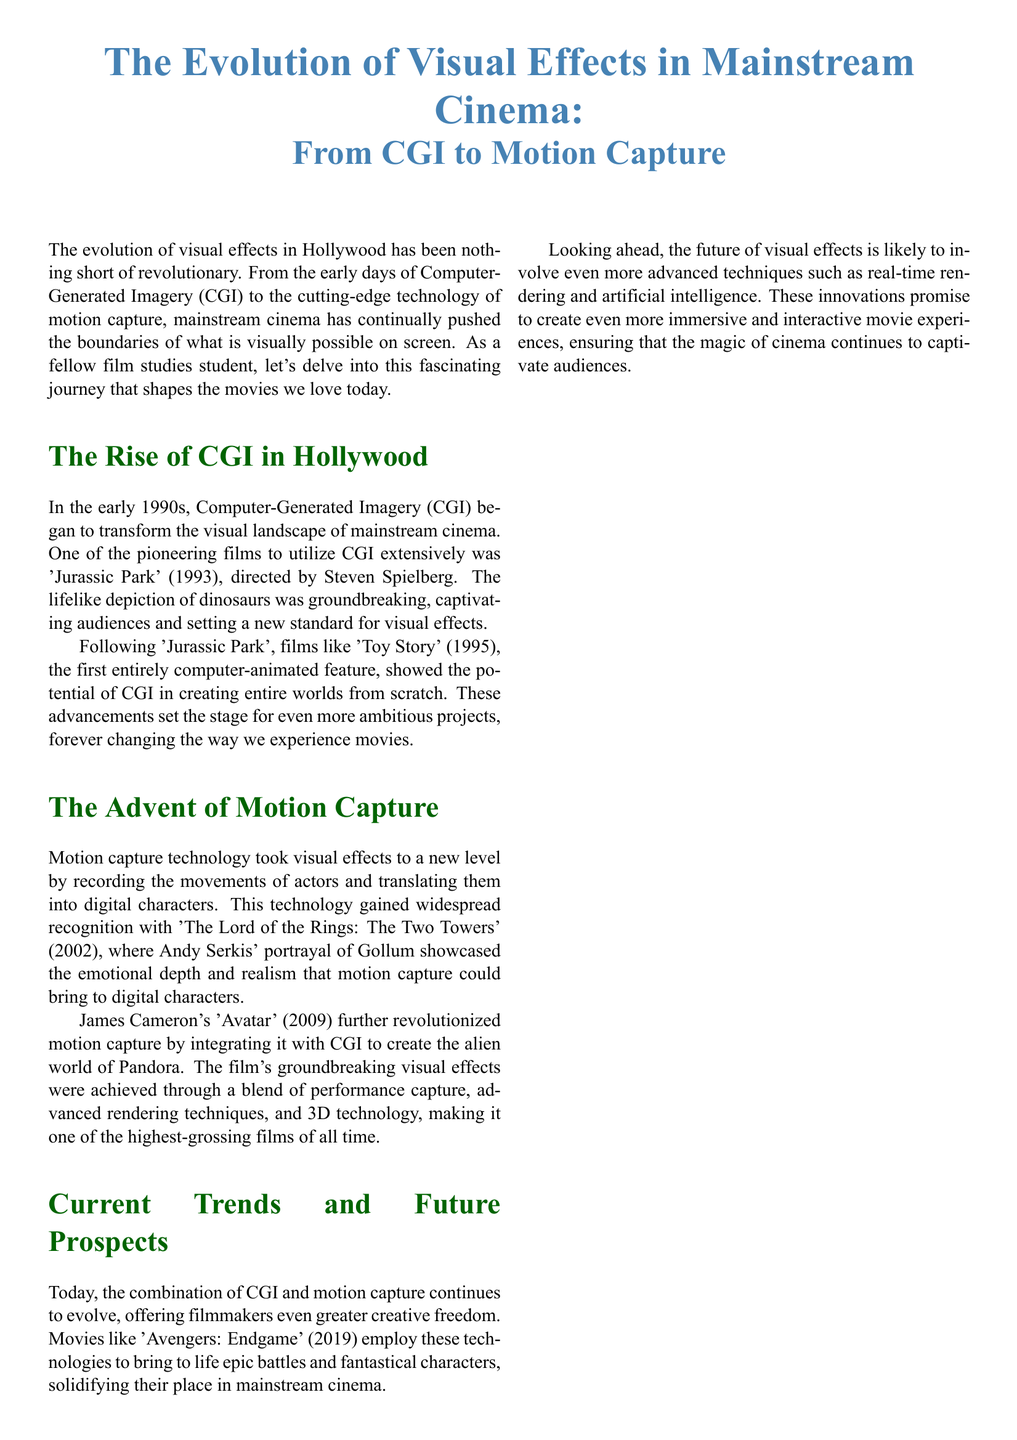What film is known for its groundbreaking use of CGI? The document states that 'Jurassic Park' was one of the pioneering films to utilize CGI extensively.
Answer: 'Jurassic Park' In what year was 'Toy Story' released? According to the document, 'Toy Story' was released in 1995.
Answer: 1995 Who portrayed Gollum in 'The Lord of the Rings: The Two Towers'? The document mentions that Andy Serkis portrayed Gollum in the film.
Answer: Andy Serkis Which film integrated motion capture with CGI to create the world of Pandora? The document notes that 'Avatar' revolutionized motion capture by integrating it with CGI.
Answer: 'Avatar' What technology is expected to play a role in the future of visual effects? The document discusses the promising role of real-time rendering and artificial intelligence for future visual effects.
Answer: Artificial intelligence What decade saw the rise of CGI in Hollywood? According to the document, CGI began to transform mainstream cinema in the early 1990s.
Answer: 1990s What is the main focus of visual effects in cinema, according to Steven Spielberg? The document cites Spielberg emphasizing that visual effects are about storytelling and taking the audience on a journey.
Answer: Storytelling Which Avengers film employs CGI and motion capture for epic battles? The document states that 'Avengers: Endgame' utilizes CGI and motion capture technologies.
Answer: 'Avengers: Endgame' What color is used for the section titles in the document? The color used for section titles is described in the document as green.
Answer: Green 